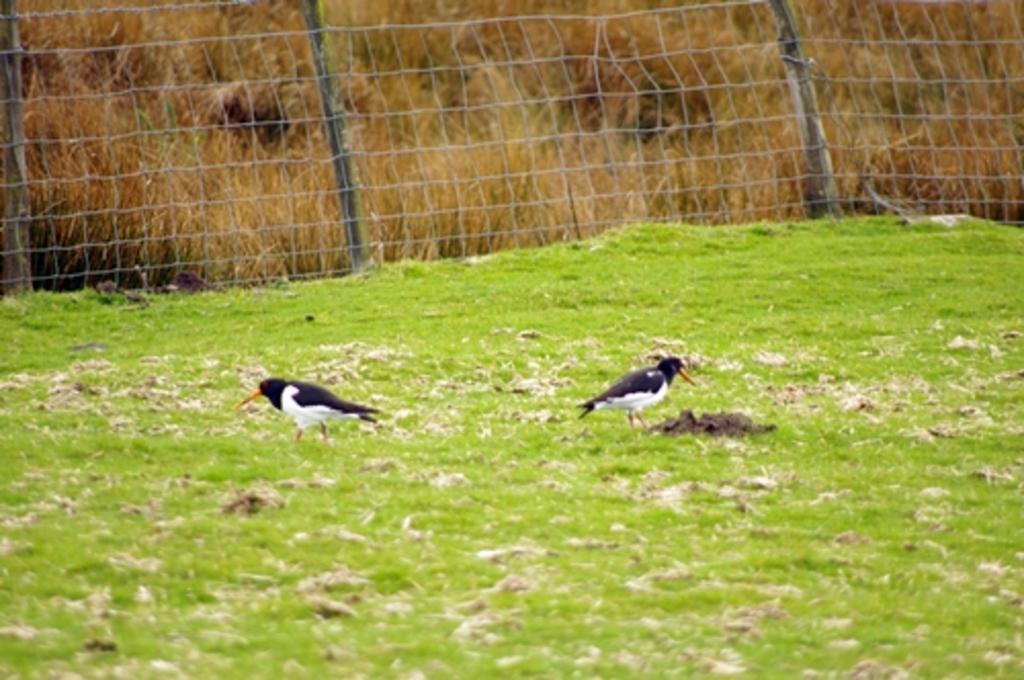How would you summarize this image in a sentence or two? In this image there is a ground. There are two birds standing on the ground. There is grass on the ground. Behind them there is a net. In the background there are dried plants. 